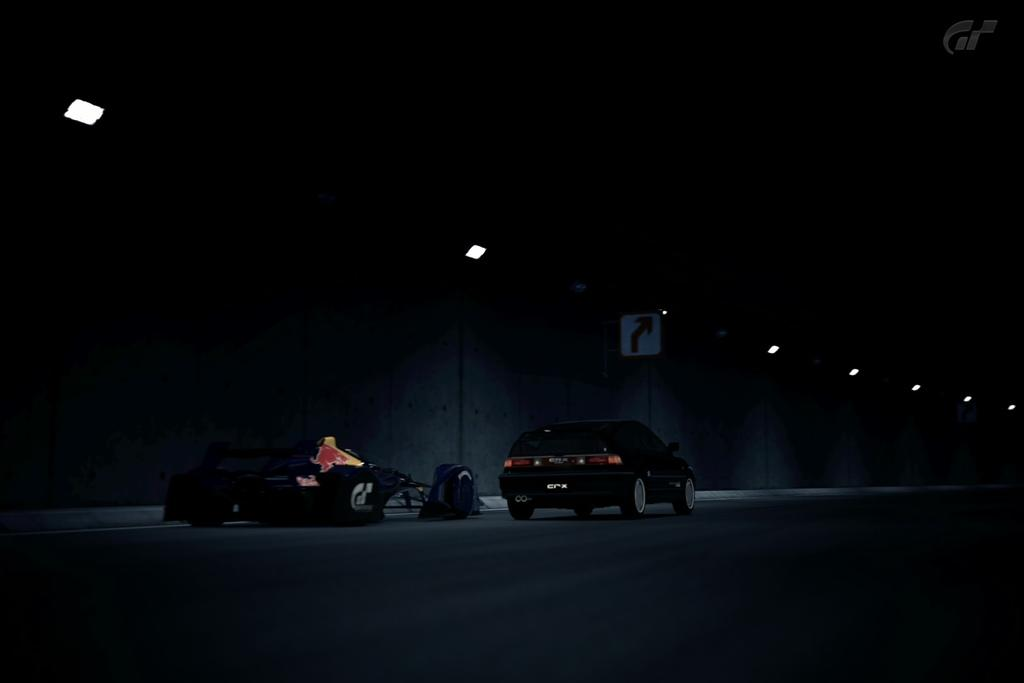What types of objects are present in the image? There are vehicles in the image. What can be used to provide directions in the image? There is a direction board in the image. What can be seen illuminating the scene in the image? There are lights in the image. How would you describe the lighting conditions in the image? The image appears to be in a dark setting. What type of income can be seen in the image? There is no reference to income in the image; it features vehicles, a direction board, and lights in a dark setting. Are there any fairies visible in the image? There are no fairies present in the image. 